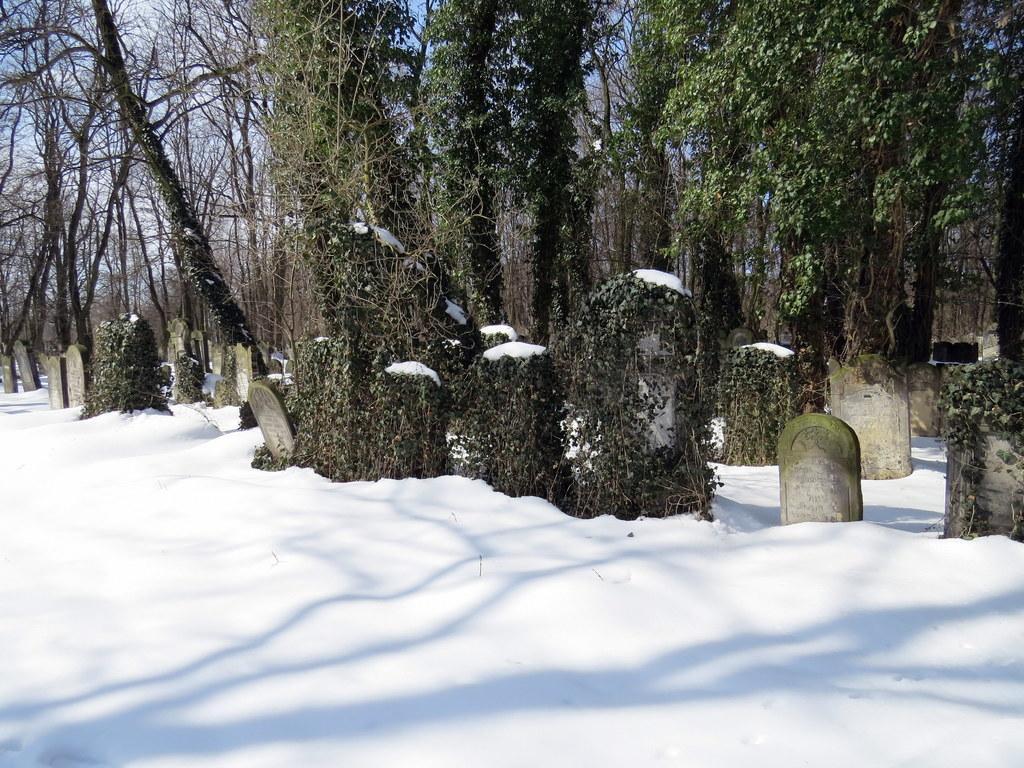How would you summarize this image in a sentence or two? This place is a graveyard. At the bottom, I can see the snow. In the background there are many creeper plants and trees. 